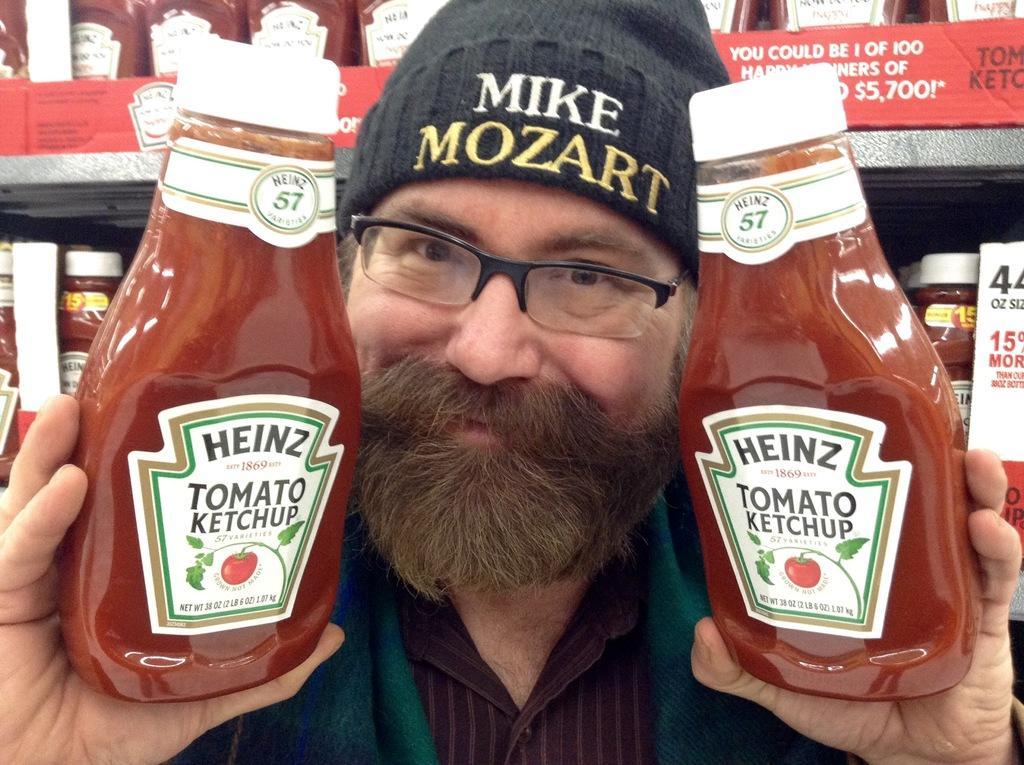In one or two sentences, can you explain what this image depicts? In this image there is a person holding ketchup bottles and smiling, behind him there is a shelf with so many jars. 